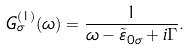Convert formula to latex. <formula><loc_0><loc_0><loc_500><loc_500>G ^ { ( 1 ) } _ { \sigma } ( \omega ) = \frac { 1 } { \omega - \tilde { \varepsilon } _ { 0 \sigma } + i \Gamma } .</formula> 